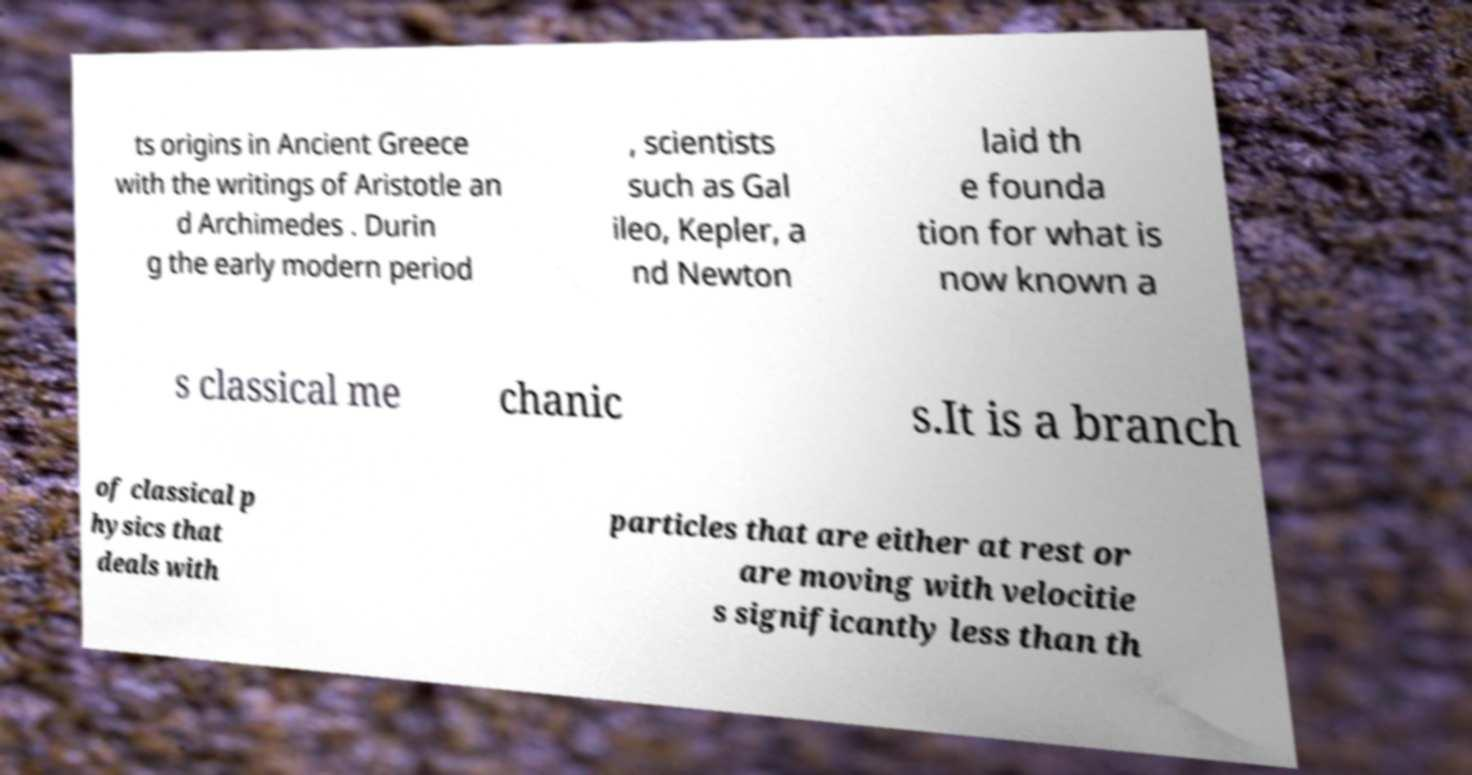Can you read and provide the text displayed in the image?This photo seems to have some interesting text. Can you extract and type it out for me? ts origins in Ancient Greece with the writings of Aristotle an d Archimedes . Durin g the early modern period , scientists such as Gal ileo, Kepler, a nd Newton laid th e founda tion for what is now known a s classical me chanic s.It is a branch of classical p hysics that deals with particles that are either at rest or are moving with velocitie s significantly less than th 